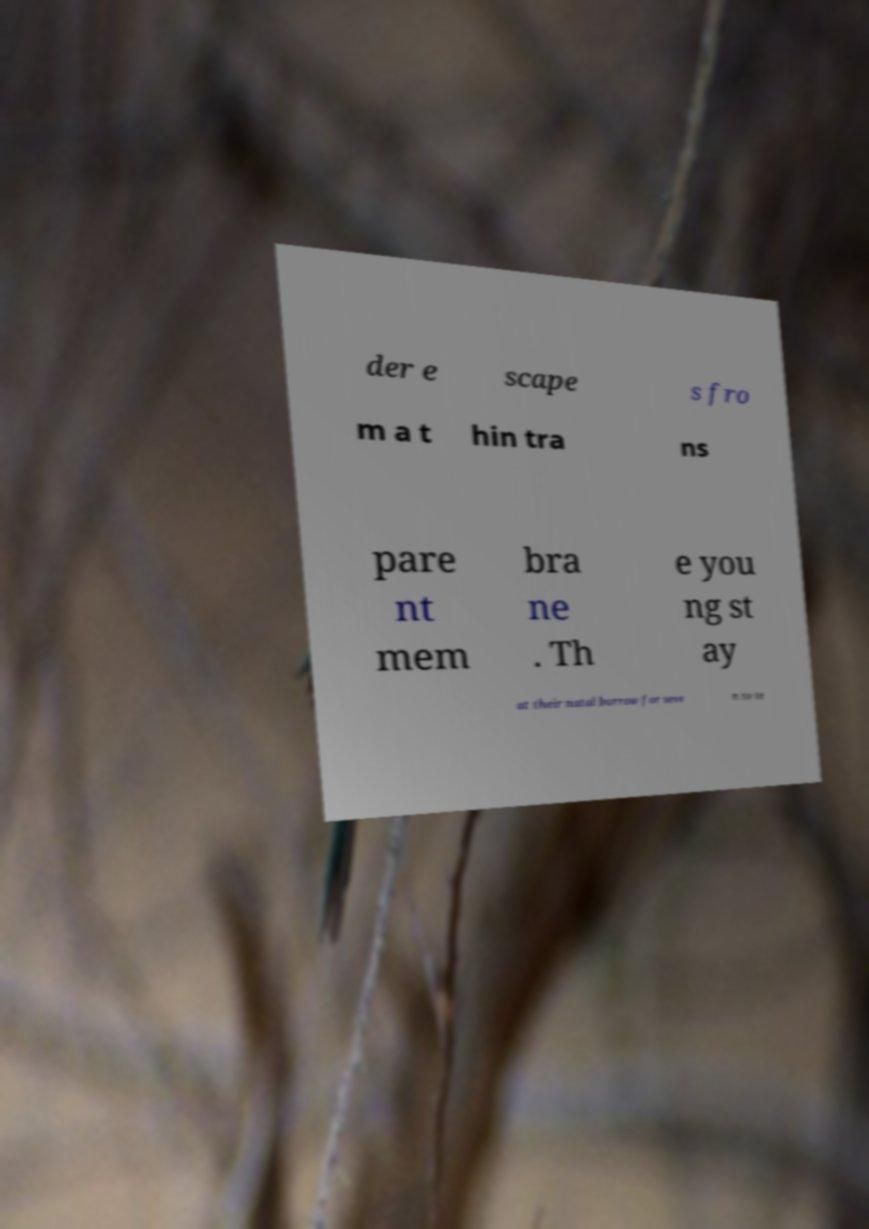There's text embedded in this image that I need extracted. Can you transcribe it verbatim? der e scape s fro m a t hin tra ns pare nt mem bra ne . Th e you ng st ay at their natal burrow for seve n to te 